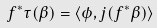Convert formula to latex. <formula><loc_0><loc_0><loc_500><loc_500>f ^ { * } \tau ( \beta ) = \langle \phi , j ( f ^ { * } \beta ) \rangle</formula> 